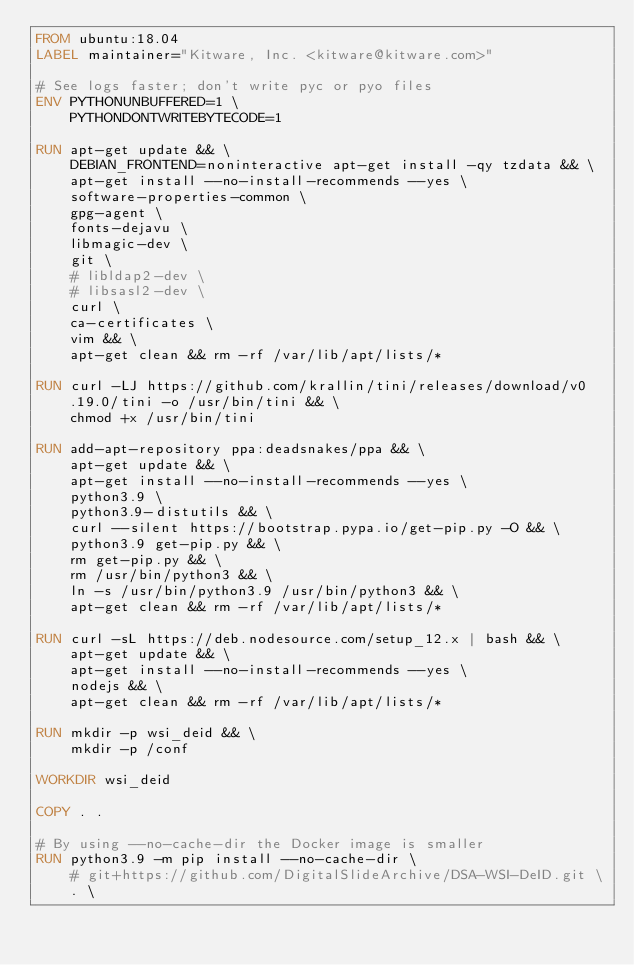<code> <loc_0><loc_0><loc_500><loc_500><_Dockerfile_>FROM ubuntu:18.04
LABEL maintainer="Kitware, Inc. <kitware@kitware.com>"

# See logs faster; don't write pyc or pyo files
ENV PYTHONUNBUFFERED=1 \
    PYTHONDONTWRITEBYTECODE=1

RUN apt-get update && \
    DEBIAN_FRONTEND=noninteractive apt-get install -qy tzdata && \
    apt-get install --no-install-recommends --yes \
    software-properties-common \
    gpg-agent \
    fonts-dejavu \
    libmagic-dev \
    git \
    # libldap2-dev \
    # libsasl2-dev \
    curl \
    ca-certificates \
    vim && \
    apt-get clean && rm -rf /var/lib/apt/lists/*

RUN curl -LJ https://github.com/krallin/tini/releases/download/v0.19.0/tini -o /usr/bin/tini && \
    chmod +x /usr/bin/tini

RUN add-apt-repository ppa:deadsnakes/ppa && \
    apt-get update && \
    apt-get install --no-install-recommends --yes \
    python3.9 \
    python3.9-distutils && \
    curl --silent https://bootstrap.pypa.io/get-pip.py -O && \
    python3.9 get-pip.py && \
    rm get-pip.py && \
    rm /usr/bin/python3 && \
    ln -s /usr/bin/python3.9 /usr/bin/python3 && \
    apt-get clean && rm -rf /var/lib/apt/lists/*

RUN curl -sL https://deb.nodesource.com/setup_12.x | bash && \
    apt-get update && \
    apt-get install --no-install-recommends --yes \
    nodejs && \
    apt-get clean && rm -rf /var/lib/apt/lists/*

RUN mkdir -p wsi_deid && \
    mkdir -p /conf

WORKDIR wsi_deid

COPY . .

# By using --no-cache-dir the Docker image is smaller
RUN python3.9 -m pip install --no-cache-dir \
    # git+https://github.com/DigitalSlideArchive/DSA-WSI-DeID.git \
    . \</code> 